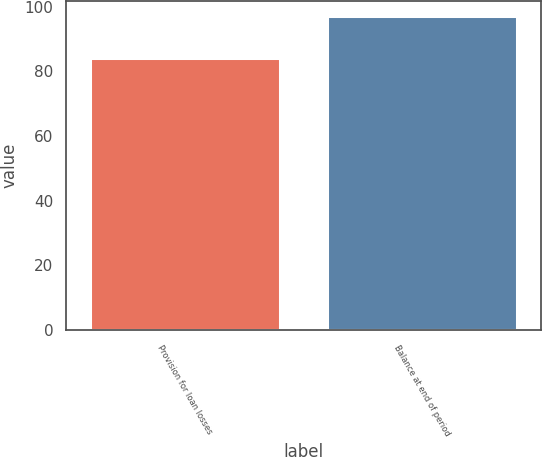Convert chart. <chart><loc_0><loc_0><loc_500><loc_500><bar_chart><fcel>Provision for loan losses<fcel>Balance at end of period<nl><fcel>84<fcel>97<nl></chart> 